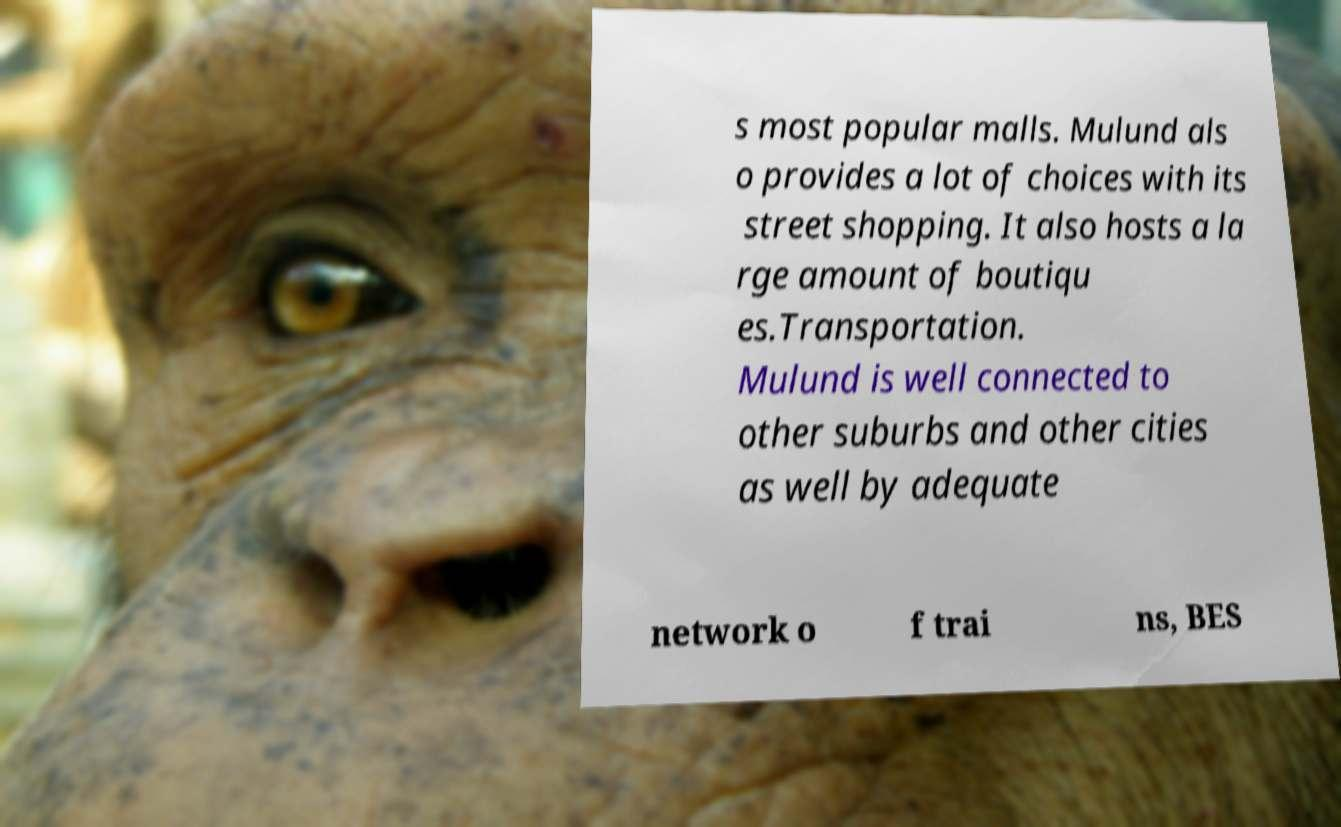What messages or text are displayed in this image? I need them in a readable, typed format. s most popular malls. Mulund als o provides a lot of choices with its street shopping. It also hosts a la rge amount of boutiqu es.Transportation. Mulund is well connected to other suburbs and other cities as well by adequate network o f trai ns, BES 